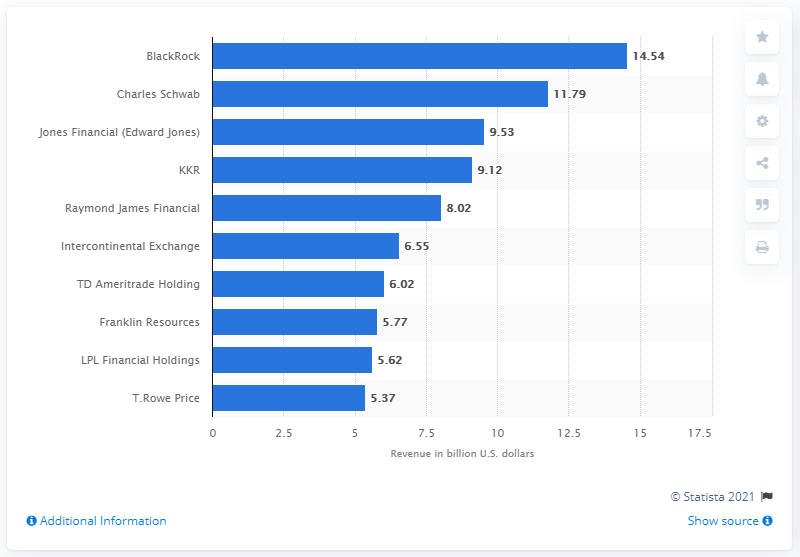Highlight a few significant elements in this photo. In 2019, the largest securities company in the United States in terms of revenue was BlackRock. In 2019, BlackRock's revenue was 14.54 billion dollars. 